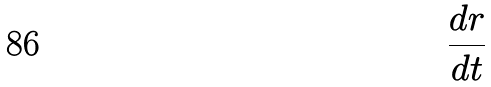<formula> <loc_0><loc_0><loc_500><loc_500>\frac { d r } { d t }</formula> 